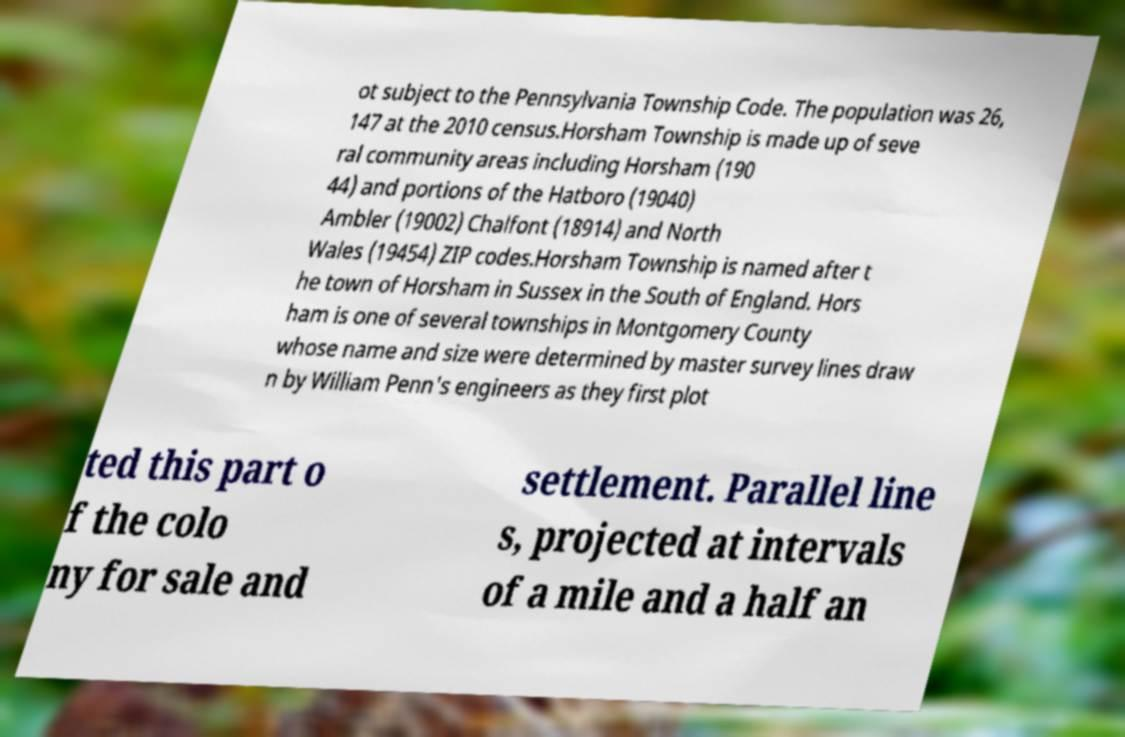Could you extract and type out the text from this image? ot subject to the Pennsylvania Township Code. The population was 26, 147 at the 2010 census.Horsham Township is made up of seve ral community areas including Horsham (190 44) and portions of the Hatboro (19040) Ambler (19002) Chalfont (18914) and North Wales (19454) ZIP codes.Horsham Township is named after t he town of Horsham in Sussex in the South of England. Hors ham is one of several townships in Montgomery County whose name and size were determined by master survey lines draw n by William Penn's engineers as they first plot ted this part o f the colo ny for sale and settlement. Parallel line s, projected at intervals of a mile and a half an 